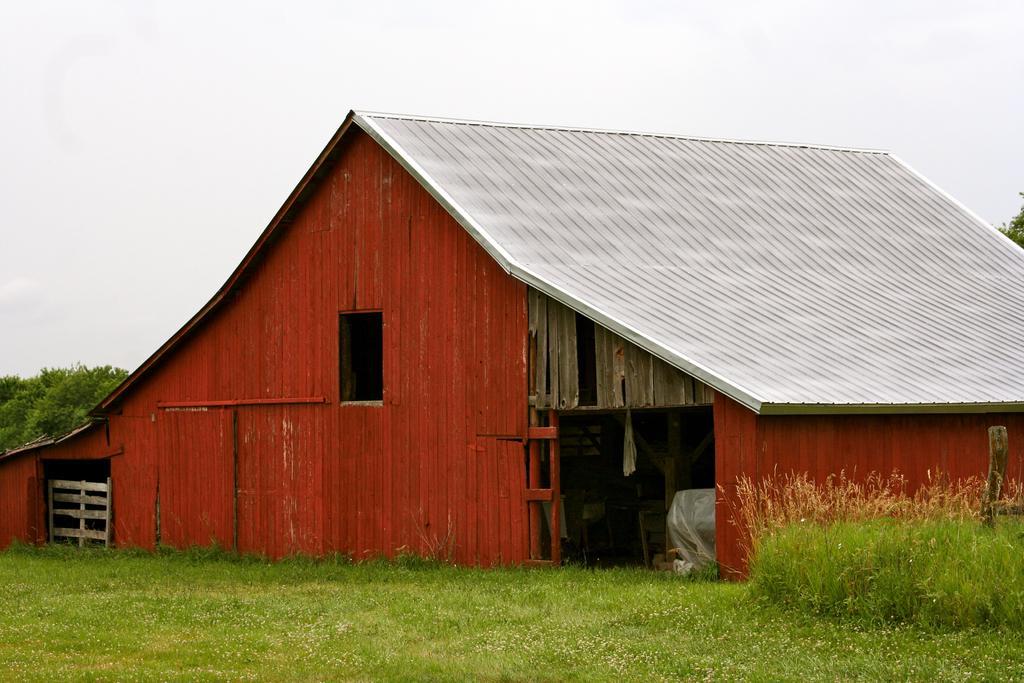How would you summarize this image in a sentence or two? At the bottom of the picture, we see grass. In the middle of the picture, we see a cottage in brown color with a grey color roof. We see a plastic cover. On the left side, we see a wooden window. There are trees in the background. At the top of the picture, we see the sky. 